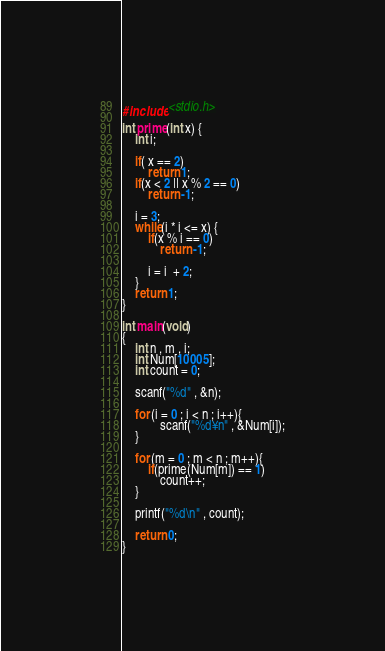Convert code to text. <code><loc_0><loc_0><loc_500><loc_500><_C_>#include <stdio.h>

int prime(int x) {
    int i;
    
    if( x == 2)
        return 1;
    if(x < 2 || x % 2 == 0)
        return -1;
        
    i = 3;
    while(i * i <= x) {
        if(x % i == 0)
            return -1;
        
        i = i  + 2;
    }
    return 1;
}

int main(void)
{
    int n , m , i;
    int Num[10005];
    int count = 0;
    
    scanf("%d" , &n);
    
    for (i = 0 ; i < n ; i++){
            scanf("%d¥n" , &Num[i]);
    }
    
    for (m = 0 ; m < n ; m++){
        if(prime(Num[m]) == 1)
            count++;
    }
    
    printf("%d\n" , count);
    
    return 0;
}

</code> 